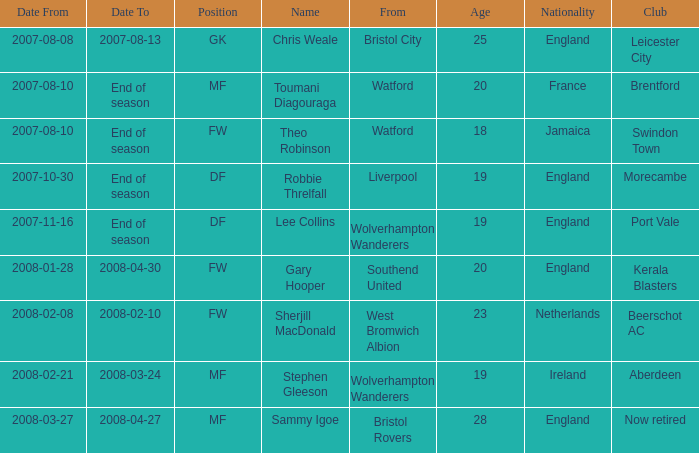What was the Date From for Theo Robinson, who was with the team until the end of season? 2007-08-10. 